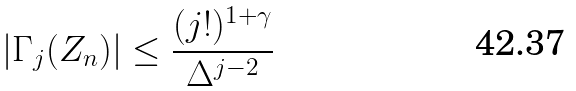Convert formula to latex. <formula><loc_0><loc_0><loc_500><loc_500>| \Gamma _ { j } ( Z _ { n } ) | \leq \frac { ( j ! ) ^ { 1 + \gamma } } { \Delta ^ { j - 2 } }</formula> 